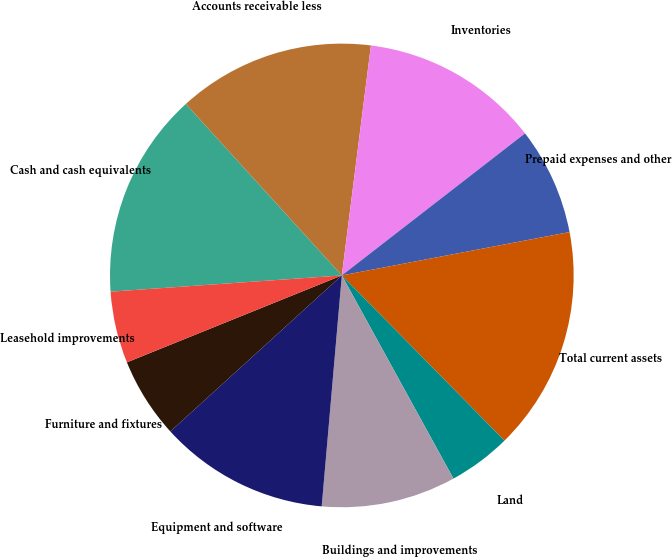<chart> <loc_0><loc_0><loc_500><loc_500><pie_chart><fcel>Cash and cash equivalents<fcel>Accounts receivable less<fcel>Inventories<fcel>Prepaid expenses and other<fcel>Total current assets<fcel>Land<fcel>Buildings and improvements<fcel>Equipment and software<fcel>Furniture and fixtures<fcel>Leasehold improvements<nl><fcel>14.37%<fcel>13.75%<fcel>12.5%<fcel>7.5%<fcel>15.62%<fcel>4.38%<fcel>9.38%<fcel>11.87%<fcel>5.63%<fcel>5.0%<nl></chart> 